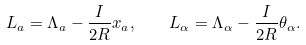Convert formula to latex. <formula><loc_0><loc_0><loc_500><loc_500>L _ { a } = \Lambda _ { a } - \frac { I } { 2 R } x _ { a } , \quad L _ { \alpha } = \Lambda _ { \alpha } - \frac { I } { 2 R } \theta _ { \alpha } .</formula> 